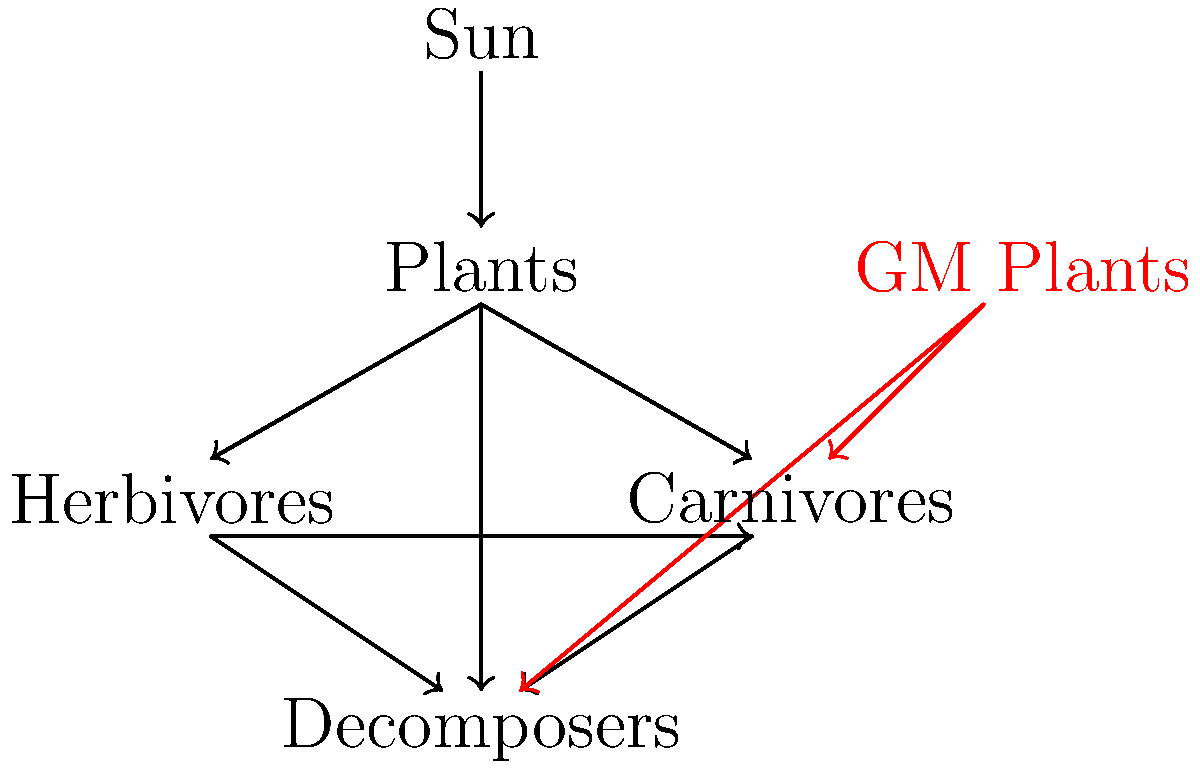In the context of releasing genetically modified (GM) plants into an ecosystem, analyze the potential cascading effects on different trophic levels as illustrated in the food web diagram. How might the introduction of GM plants with enhanced pest resistance impact the population dynamics of herbivores, carnivores, and decomposers? Consider both direct and indirect effects in your response. To analyze the ecological impact of releasing GM plants with enhanced pest resistance, we need to consider the interactions at each trophic level:

1. GM Plants to Herbivores:
   - Direct effect: Reduced herbivore population due to enhanced pest resistance.
   - This could lead to a decrease in the herbivore population, as represented by a weaker arrow from GM plants to herbivores in the diagram.

2. Herbivores to Carnivores:
   - Indirect effect: Reduced food source for carnivores.
   - With fewer herbivores, the carnivore population may decrease due to limited prey availability.

3. Plants and Herbivores to Decomposers:
   - Indirect effect: Altered input to decomposer community.
   - Changes in plant and herbivore populations will affect the amount and composition of organic matter available to decomposers.

4. Nutrient Cycling:
   - Indirect effect: Modified nutrient cycling in the ecosystem.
   - Changes in decomposer activity may alter nutrient availability for plants, potentially affecting their growth and composition.

5. Competitive Interactions:
   - Indirect effect: Altered competitive balance between GM and non-GM plants.
   - GM plants may have a competitive advantage, potentially reducing biodiversity.

6. Unintended Consequences:
   - Potential development of resistance in pest species over time.
   - Possible effects on non-target organisms, including beneficial insects.

7. Ecosystem Stability:
   - Overall impact on ecosystem resilience and stability due to altered species interactions and energy flow.

The introduction of GM plants could lead to a restructuring of the food web, with potential long-term consequences for biodiversity and ecosystem functioning. The magnitude and direction of these effects would depend on the specific traits of the GM plants and the characteristics of the ecosystem.
Answer: Cascading effects across trophic levels, altering population dynamics and ecosystem stability. 